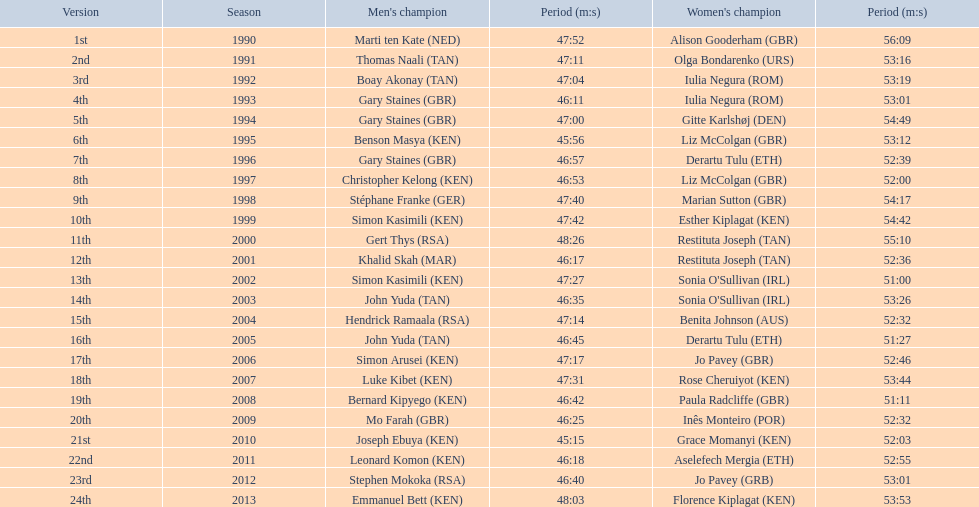What are the names of each male winner? Marti ten Kate (NED), Thomas Naali (TAN), Boay Akonay (TAN), Gary Staines (GBR), Gary Staines (GBR), Benson Masya (KEN), Gary Staines (GBR), Christopher Kelong (KEN), Stéphane Franke (GER), Simon Kasimili (KEN), Gert Thys (RSA), Khalid Skah (MAR), Simon Kasimili (KEN), John Yuda (TAN), Hendrick Ramaala (RSA), John Yuda (TAN), Simon Arusei (KEN), Luke Kibet (KEN), Bernard Kipyego (KEN), Mo Farah (GBR), Joseph Ebuya (KEN), Leonard Komon (KEN), Stephen Mokoka (RSA), Emmanuel Bett (KEN). When did they race? 1990, 1991, 1992, 1993, 1994, 1995, 1996, 1997, 1998, 1999, 2000, 2001, 2002, 2003, 2004, 2005, 2006, 2007, 2008, 2009, 2010, 2011, 2012, 2013. And what were their times? 47:52, 47:11, 47:04, 46:11, 47:00, 45:56, 46:57, 46:53, 47:40, 47:42, 48:26, 46:17, 47:27, 46:35, 47:14, 46:45, 47:17, 47:31, 46:42, 46:25, 45:15, 46:18, 46:40, 48:03. Of those times, which athlete had the fastest time? Joseph Ebuya (KEN). 